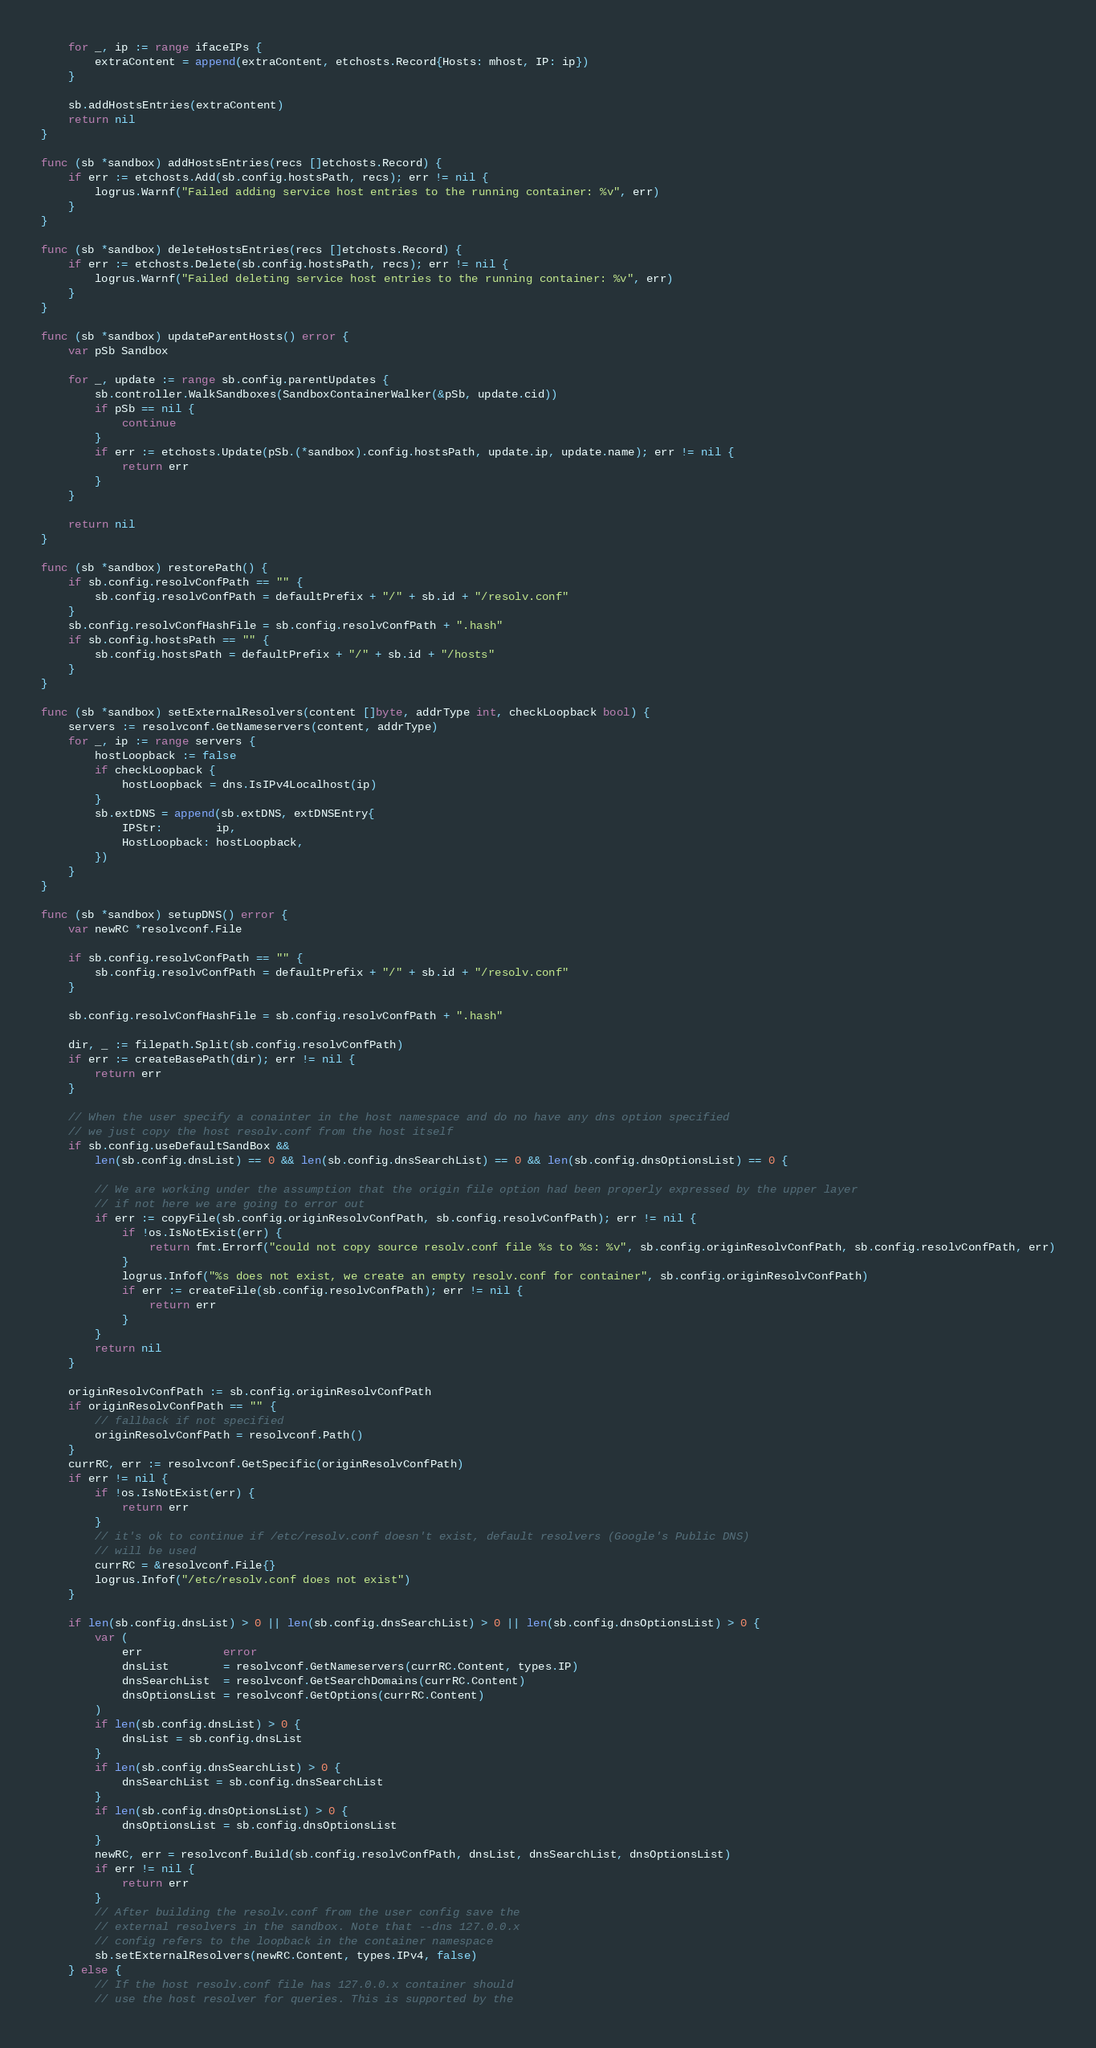Convert code to text. <code><loc_0><loc_0><loc_500><loc_500><_Go_>	for _, ip := range ifaceIPs {
		extraContent = append(extraContent, etchosts.Record{Hosts: mhost, IP: ip})
	}

	sb.addHostsEntries(extraContent)
	return nil
}

func (sb *sandbox) addHostsEntries(recs []etchosts.Record) {
	if err := etchosts.Add(sb.config.hostsPath, recs); err != nil {
		logrus.Warnf("Failed adding service host entries to the running container: %v", err)
	}
}

func (sb *sandbox) deleteHostsEntries(recs []etchosts.Record) {
	if err := etchosts.Delete(sb.config.hostsPath, recs); err != nil {
		logrus.Warnf("Failed deleting service host entries to the running container: %v", err)
	}
}

func (sb *sandbox) updateParentHosts() error {
	var pSb Sandbox

	for _, update := range sb.config.parentUpdates {
		sb.controller.WalkSandboxes(SandboxContainerWalker(&pSb, update.cid))
		if pSb == nil {
			continue
		}
		if err := etchosts.Update(pSb.(*sandbox).config.hostsPath, update.ip, update.name); err != nil {
			return err
		}
	}

	return nil
}

func (sb *sandbox) restorePath() {
	if sb.config.resolvConfPath == "" {
		sb.config.resolvConfPath = defaultPrefix + "/" + sb.id + "/resolv.conf"
	}
	sb.config.resolvConfHashFile = sb.config.resolvConfPath + ".hash"
	if sb.config.hostsPath == "" {
		sb.config.hostsPath = defaultPrefix + "/" + sb.id + "/hosts"
	}
}

func (sb *sandbox) setExternalResolvers(content []byte, addrType int, checkLoopback bool) {
	servers := resolvconf.GetNameservers(content, addrType)
	for _, ip := range servers {
		hostLoopback := false
		if checkLoopback {
			hostLoopback = dns.IsIPv4Localhost(ip)
		}
		sb.extDNS = append(sb.extDNS, extDNSEntry{
			IPStr:        ip,
			HostLoopback: hostLoopback,
		})
	}
}

func (sb *sandbox) setupDNS() error {
	var newRC *resolvconf.File

	if sb.config.resolvConfPath == "" {
		sb.config.resolvConfPath = defaultPrefix + "/" + sb.id + "/resolv.conf"
	}

	sb.config.resolvConfHashFile = sb.config.resolvConfPath + ".hash"

	dir, _ := filepath.Split(sb.config.resolvConfPath)
	if err := createBasePath(dir); err != nil {
		return err
	}

	// When the user specify a conainter in the host namespace and do no have any dns option specified
	// we just copy the host resolv.conf from the host itself
	if sb.config.useDefaultSandBox &&
		len(sb.config.dnsList) == 0 && len(sb.config.dnsSearchList) == 0 && len(sb.config.dnsOptionsList) == 0 {

		// We are working under the assumption that the origin file option had been properly expressed by the upper layer
		// if not here we are going to error out
		if err := copyFile(sb.config.originResolvConfPath, sb.config.resolvConfPath); err != nil {
			if !os.IsNotExist(err) {
				return fmt.Errorf("could not copy source resolv.conf file %s to %s: %v", sb.config.originResolvConfPath, sb.config.resolvConfPath, err)
			}
			logrus.Infof("%s does not exist, we create an empty resolv.conf for container", sb.config.originResolvConfPath)
			if err := createFile(sb.config.resolvConfPath); err != nil {
				return err
			}
		}
		return nil
	}

	originResolvConfPath := sb.config.originResolvConfPath
	if originResolvConfPath == "" {
		// fallback if not specified
		originResolvConfPath = resolvconf.Path()
	}
	currRC, err := resolvconf.GetSpecific(originResolvConfPath)
	if err != nil {
		if !os.IsNotExist(err) {
			return err
		}
		// it's ok to continue if /etc/resolv.conf doesn't exist, default resolvers (Google's Public DNS)
		// will be used
		currRC = &resolvconf.File{}
		logrus.Infof("/etc/resolv.conf does not exist")
	}

	if len(sb.config.dnsList) > 0 || len(sb.config.dnsSearchList) > 0 || len(sb.config.dnsOptionsList) > 0 {
		var (
			err            error
			dnsList        = resolvconf.GetNameservers(currRC.Content, types.IP)
			dnsSearchList  = resolvconf.GetSearchDomains(currRC.Content)
			dnsOptionsList = resolvconf.GetOptions(currRC.Content)
		)
		if len(sb.config.dnsList) > 0 {
			dnsList = sb.config.dnsList
		}
		if len(sb.config.dnsSearchList) > 0 {
			dnsSearchList = sb.config.dnsSearchList
		}
		if len(sb.config.dnsOptionsList) > 0 {
			dnsOptionsList = sb.config.dnsOptionsList
		}
		newRC, err = resolvconf.Build(sb.config.resolvConfPath, dnsList, dnsSearchList, dnsOptionsList)
		if err != nil {
			return err
		}
		// After building the resolv.conf from the user config save the
		// external resolvers in the sandbox. Note that --dns 127.0.0.x
		// config refers to the loopback in the container namespace
		sb.setExternalResolvers(newRC.Content, types.IPv4, false)
	} else {
		// If the host resolv.conf file has 127.0.0.x container should
		// use the host resolver for queries. This is supported by the</code> 